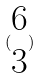<formula> <loc_0><loc_0><loc_500><loc_500>( \begin{matrix} 6 \\ 3 \end{matrix} )</formula> 